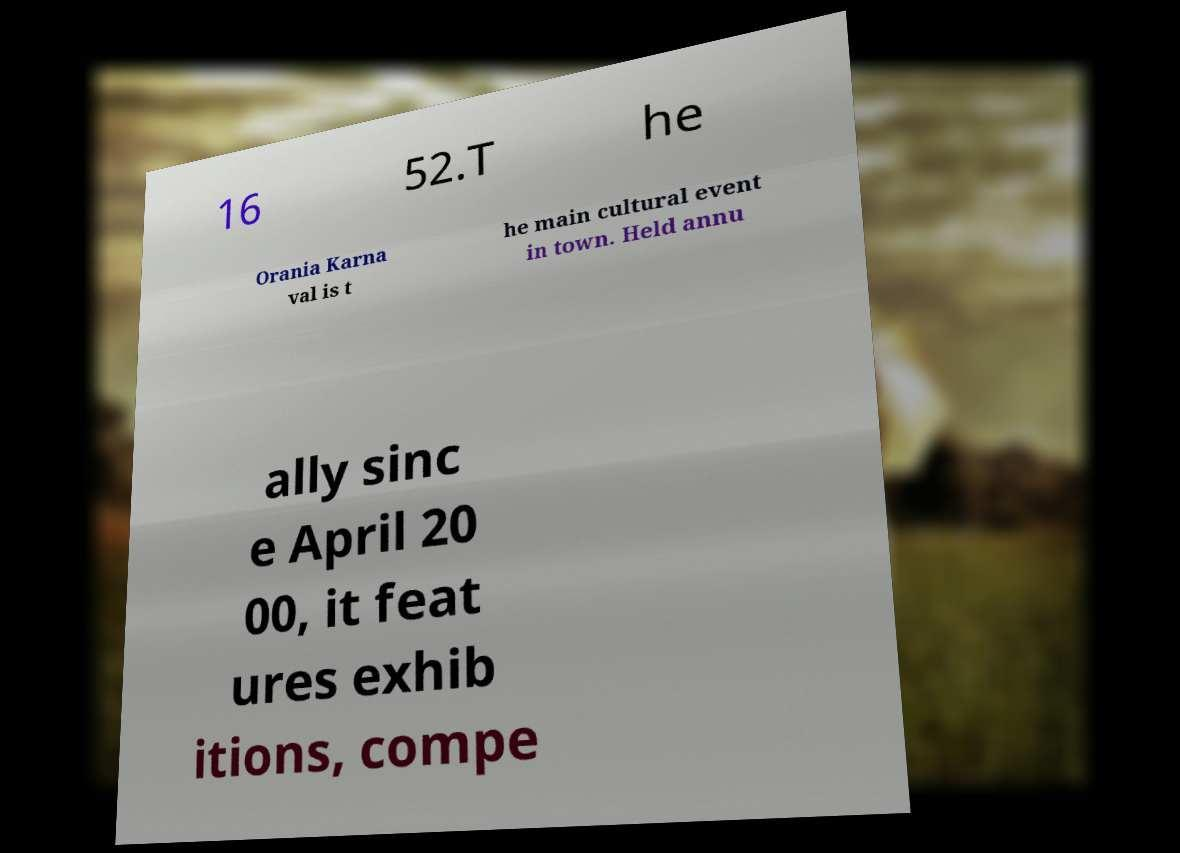Can you read and provide the text displayed in the image?This photo seems to have some interesting text. Can you extract and type it out for me? 16 52.T he Orania Karna val is t he main cultural event in town. Held annu ally sinc e April 20 00, it feat ures exhib itions, compe 